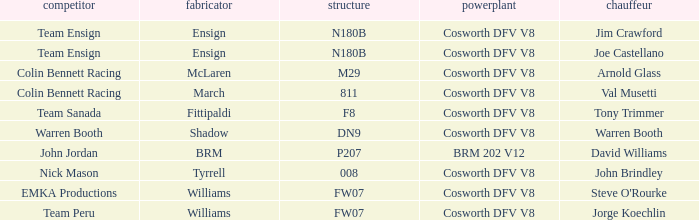Can you give me this table as a dict? {'header': ['competitor', 'fabricator', 'structure', 'powerplant', 'chauffeur'], 'rows': [['Team Ensign', 'Ensign', 'N180B', 'Cosworth DFV V8', 'Jim Crawford'], ['Team Ensign', 'Ensign', 'N180B', 'Cosworth DFV V8', 'Joe Castellano'], ['Colin Bennett Racing', 'McLaren', 'M29', 'Cosworth DFV V8', 'Arnold Glass'], ['Colin Bennett Racing', 'March', '811', 'Cosworth DFV V8', 'Val Musetti'], ['Team Sanada', 'Fittipaldi', 'F8', 'Cosworth DFV V8', 'Tony Trimmer'], ['Warren Booth', 'Shadow', 'DN9', 'Cosworth DFV V8', 'Warren Booth'], ['John Jordan', 'BRM', 'P207', 'BRM 202 V12', 'David Williams'], ['Nick Mason', 'Tyrrell', '008', 'Cosworth DFV V8', 'John Brindley'], ['EMKA Productions', 'Williams', 'FW07', 'Cosworth DFV V8', "Steve O'Rourke"], ['Team Peru', 'Williams', 'FW07', 'Cosworth DFV V8', 'Jorge Koechlin']]} What chassis does the shadow built car use? DN9. 